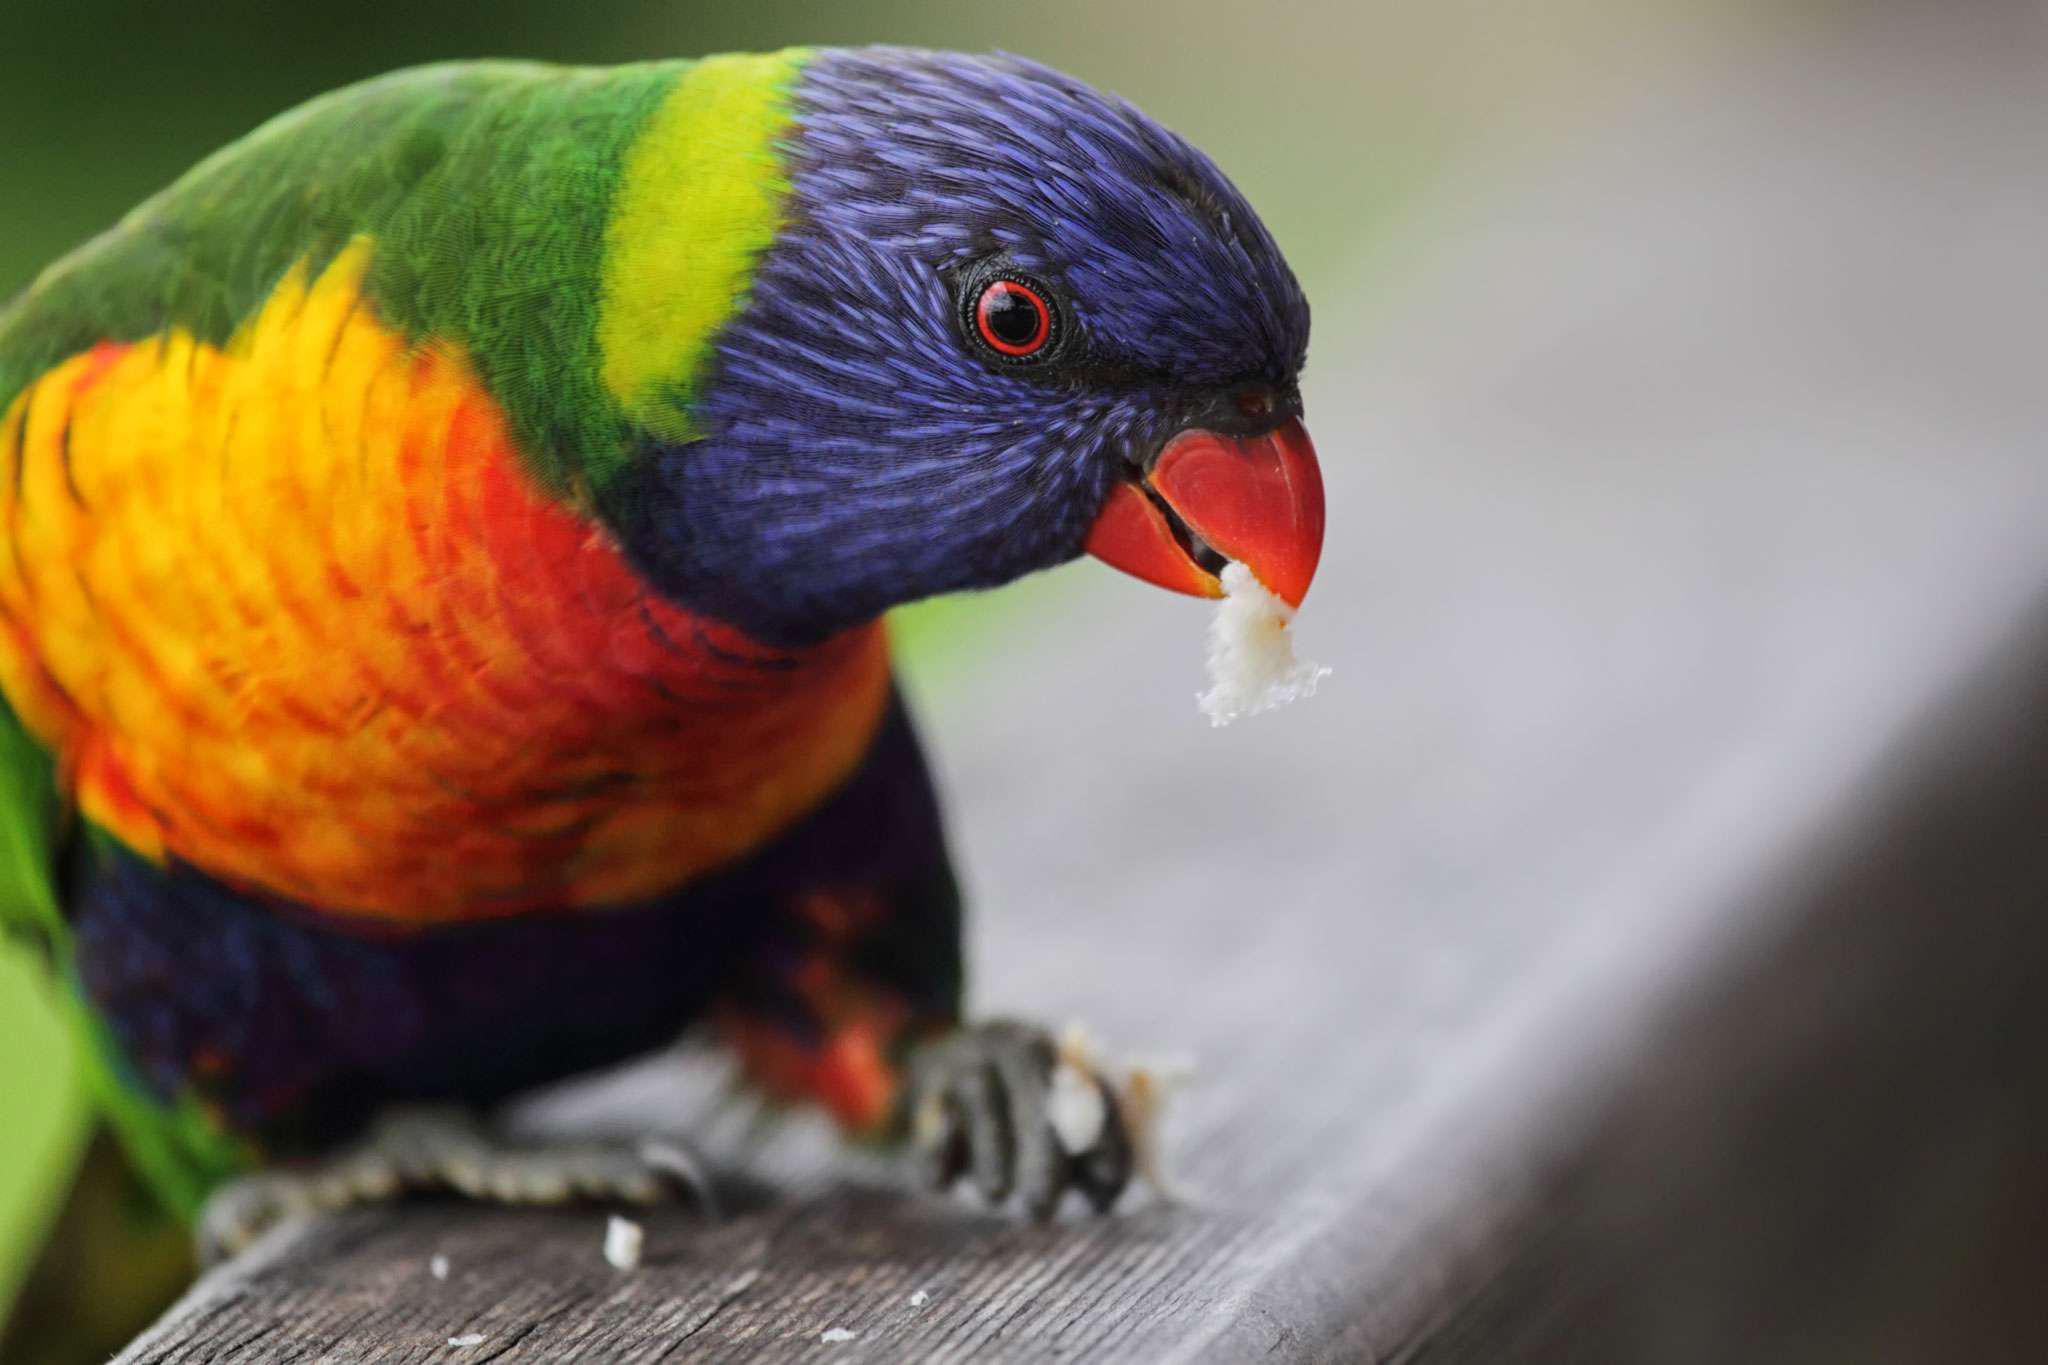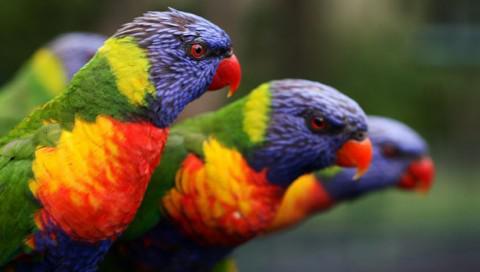The first image is the image on the left, the second image is the image on the right. For the images shown, is this caption "There are two birds" true? Answer yes or no. No. The first image is the image on the left, the second image is the image on the right. Assess this claim about the two images: "There are two birds". Correct or not? Answer yes or no. No. 